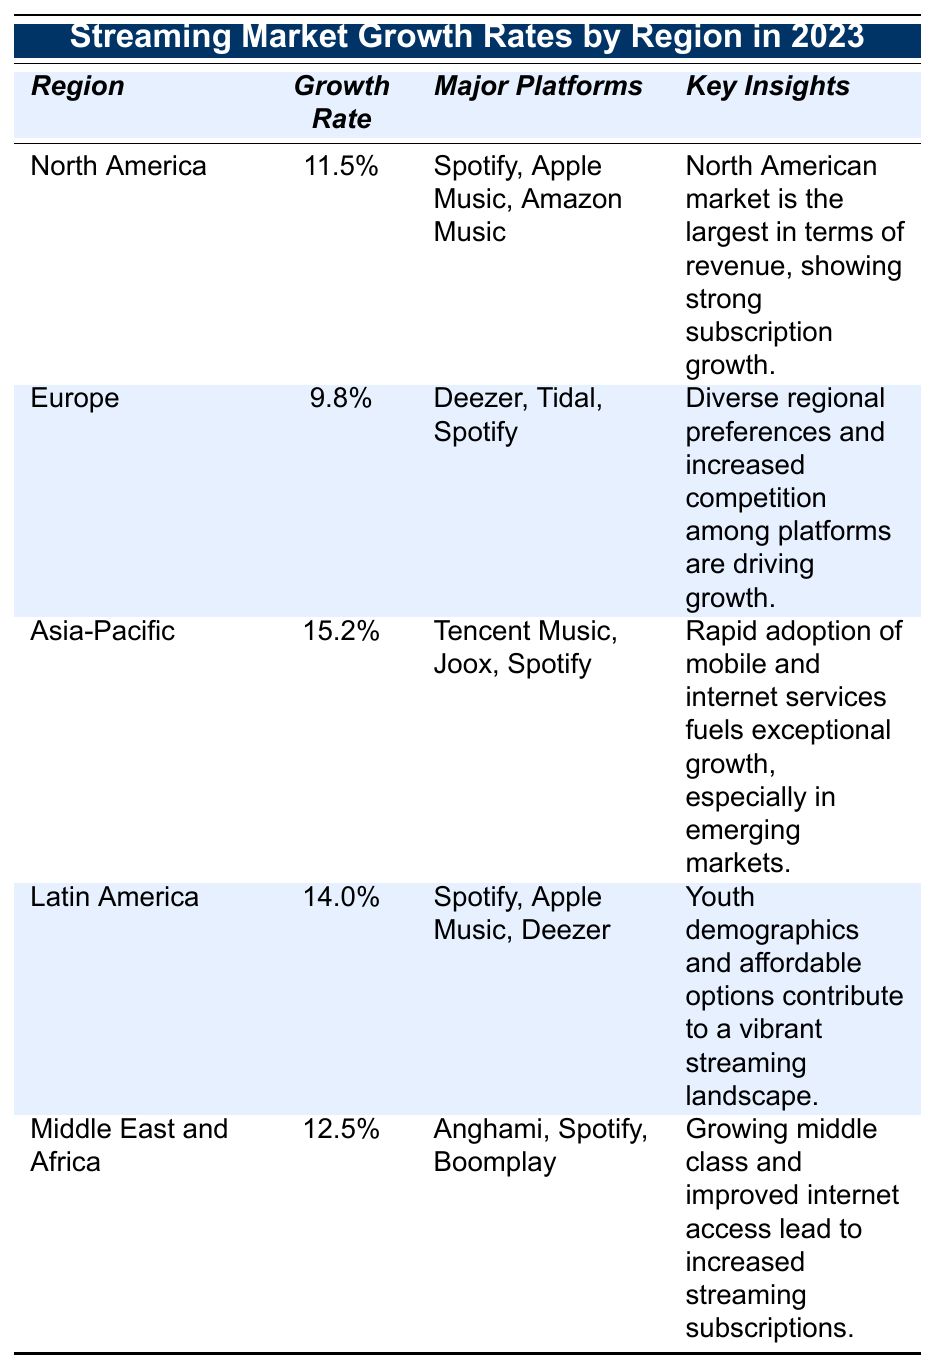What is the growth rate of the Asia-Pacific region? The table indicates that the growth rate for the Asia-Pacific region is 15.2%.
Answer: 15.2% Which major platforms are listed for the European market? The major platforms for Europe, as per the table, are Deezer, Tidal, and Spotify.
Answer: Deezer, Tidal, Spotify Is the growth rate in North America higher than that in Europe? The growth rate in North America is 11.5%, while Europe has a growth rate of 9.8%, meaning North America's rate is higher.
Answer: Yes Calculate the average growth rate for Latin America and Asia-Pacific. The growth rates for Latin America and Asia-Pacific are 14.0% and 15.2%, respectively. The average is calculated as (14.0% + 15.2%) / 2 = 14.6%.
Answer: 14.6% Which region has the highest growth rate and what is it? The Asia-Pacific region has the highest growth rate of 15.2%.
Answer: Asia-Pacific, 15.2% Are the major platforms in the Middle East and Africa the same as in North America? The Middle East and Africa has Anghami, Spotify, and Boomplay as major platforms, while North America has Spotify, Apple Music, and Amazon Music, indicating different platforms.
Answer: No What can be inferred about streaming growth in the Latin America region? The table notes that youth demographics and affordable options contribute to a vibrant streaming landscape in Latin America, indicating strong growth potential.
Answer: Strong growth potential If North America shows a growth rate of 11.5% and Asia-Pacific shows 15.2%, what is the difference in growth rates between these two regions? The difference is calculated as 15.2% - 11.5% = 3.7%, showing that Asia-Pacific has a much higher growth rate than North America.
Answer: 3.7% Which region shows the greatest potential for growth based on key insights? The key insights for Asia-Pacific point to exceptional growth fueled by rapid adoption of mobile and internet services, suggesting it has the greatest potential.
Answer: Asia-Pacific Is there a significant difference in growth rates between Europe and the Middle East and Africa? Europe has a growth rate of 9.8%, while the Middle East and Africa has a rate of 12.5%. The difference is 2.7%, indicating that the Middle East and Africa is growing faster.
Answer: Yes, 2.7% difference 